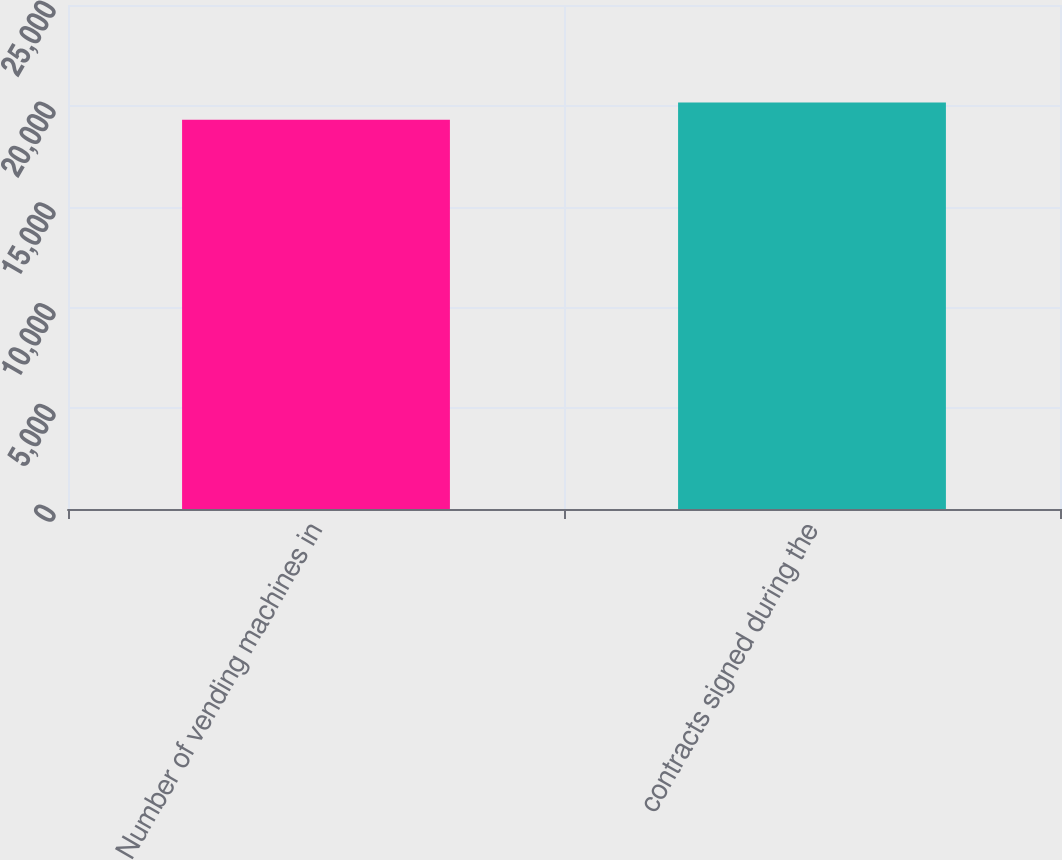<chart> <loc_0><loc_0><loc_500><loc_500><bar_chart><fcel>Number of vending machines in<fcel>contracts signed during the<nl><fcel>19305<fcel>20162<nl></chart> 